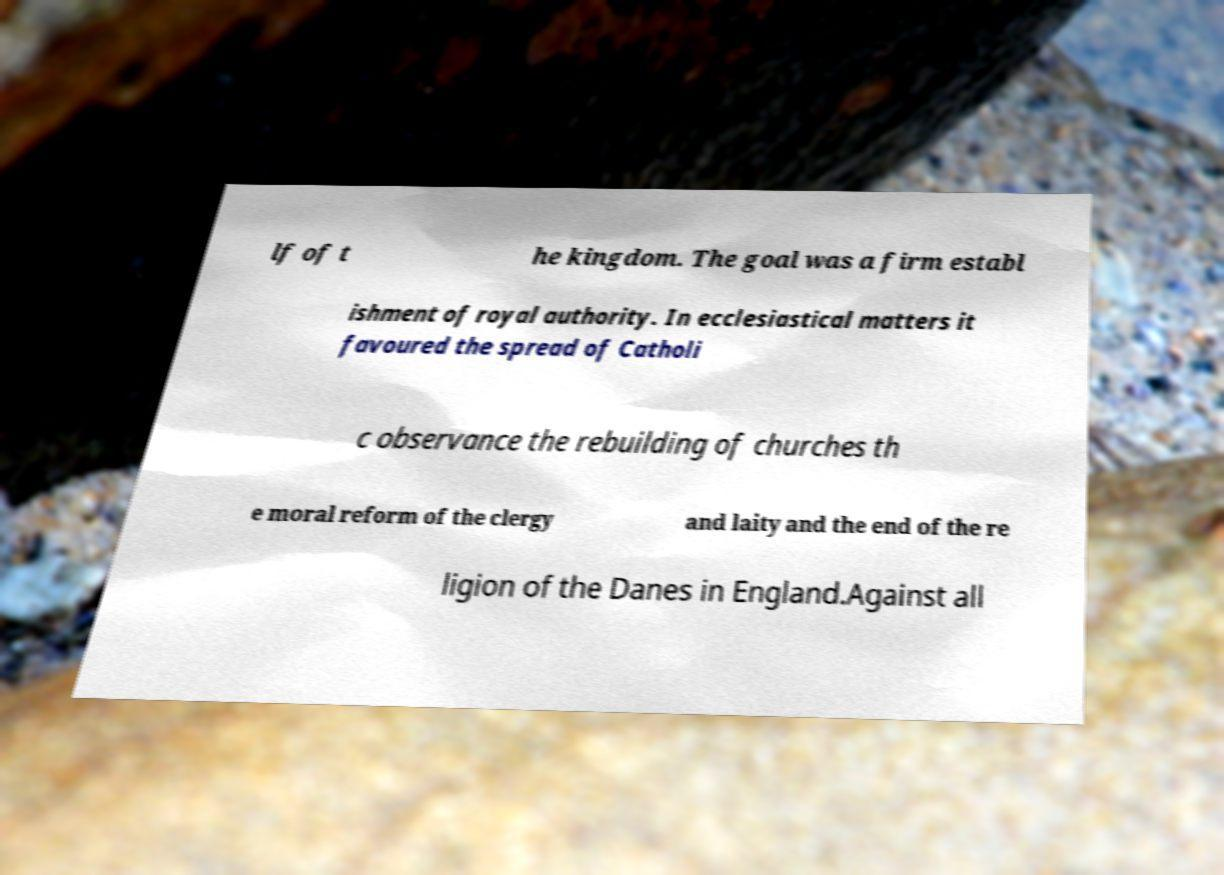Can you read and provide the text displayed in the image?This photo seems to have some interesting text. Can you extract and type it out for me? lf of t he kingdom. The goal was a firm establ ishment of royal authority. In ecclesiastical matters it favoured the spread of Catholi c observance the rebuilding of churches th e moral reform of the clergy and laity and the end of the re ligion of the Danes in England.Against all 